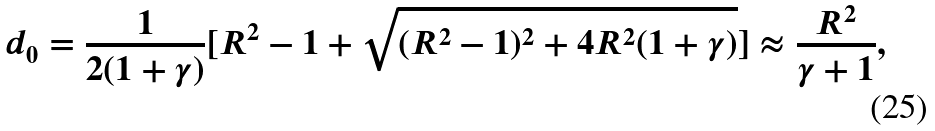<formula> <loc_0><loc_0><loc_500><loc_500>d _ { 0 } = \frac { 1 } { 2 ( 1 + \gamma ) } [ R ^ { 2 } - 1 + \sqrt { ( R ^ { 2 } - 1 ) ^ { 2 } + 4 R ^ { 2 } ( 1 + \gamma ) } ] \approx \frac { R ^ { 2 } } { \gamma + 1 } ,</formula> 